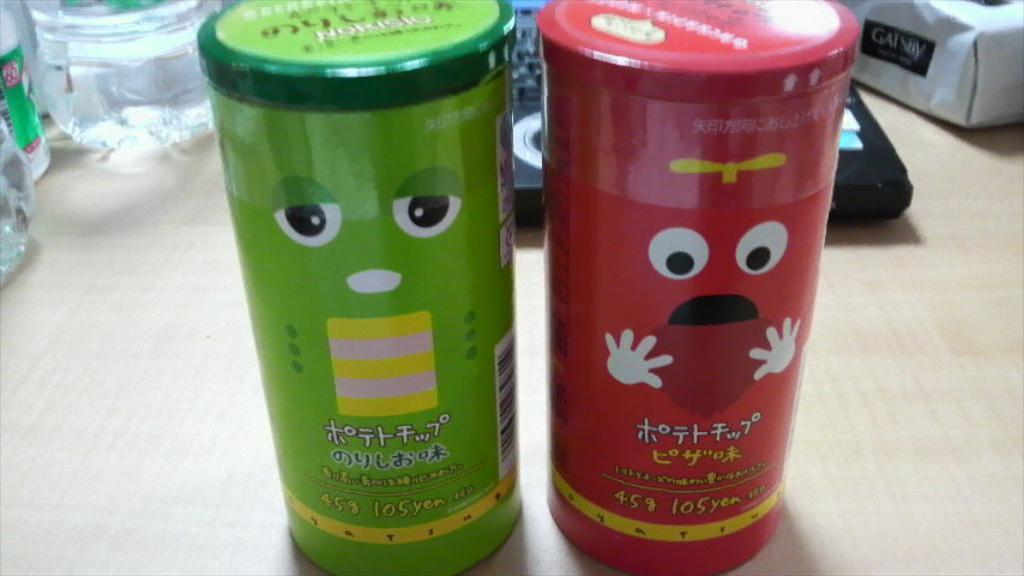How would you summarize this image in a sentence or two? These are the two bottles with the paints on it. 